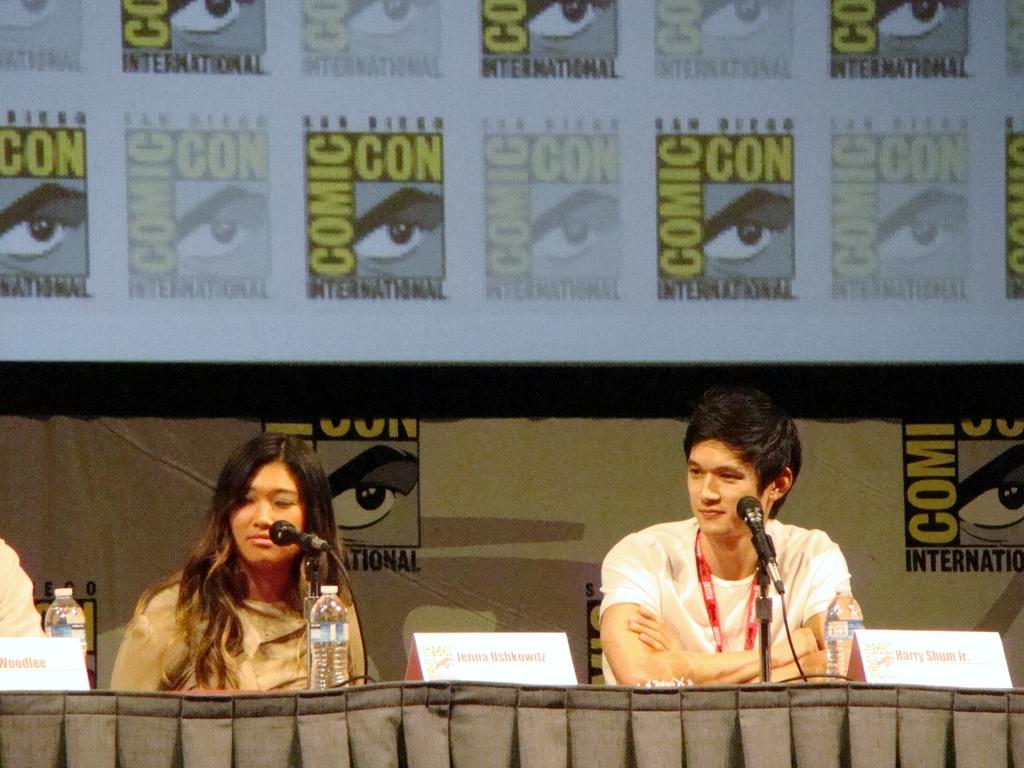How many people are present in the image? There are two persons sitting in the image. What objects are visible near the persons? There are microphones and water bottles in the image. What can be seen on the table in the image? There are nameplates on the table in the image. What is visible in the background of the image? There is a projector screen and a board in the background of the image. What type of soup is being offered to the persons in the image? There is no soup present in the image; it features two persons sitting with microphones and water bottles on a table with nameplates, and a projector screen and a board in the background. Can you tell me how many baths are visible in the image? There are no baths present in the image. 